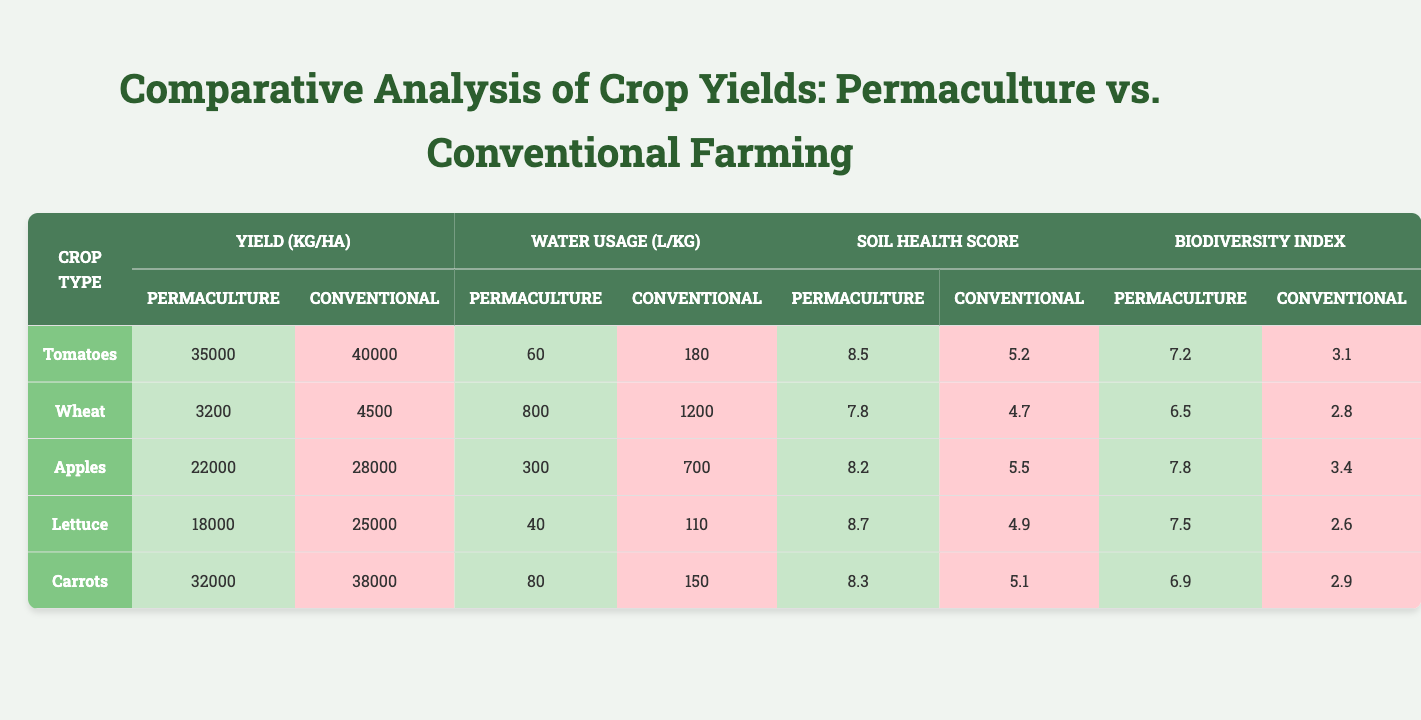What is the yield of tomatoes in the permaculture system? According to the table, the yield of tomatoes grown in the permaculture system is listed as 35,000 kg/ha.
Answer: 35,000 kg/ha What is the water usage for conventional lettuce farming? The table shows that the water usage for conventional lettuce farming is 110 L/kg.
Answer: 110 L/kg Which crop has the highest soil health score in the permaculture system? By comparing the soil health scores in the permaculture section of the table, we see that lettuce has the highest score of 8.7.
Answer: Lettuce How much more yield do conventional tomatoes produce compared to permaculture tomatoes? The yield for conventional tomatoes is 40,000 kg/ha and for permaculture tomatoes, it is 35,000 kg/ha. The difference is 40,000 - 35,000 = 5,000 kg/ha.
Answer: 5,000 kg/ha What is the average biodiversity index for the crops in the permaculture system? The biodiversity indices for permaculture crops are 7.2 (tomatoes), 6.5 (wheat), 7.8 (apples), 7.5 (lettuce), and 6.9 (carrots). To find the average, sum these values: 7.2 + 6.5 + 7.8 + 7.5 + 6.9 = 36.9. Then divide by 5, giving 36.9 / 5 = 7.38.
Answer: 7.38 Is it true that conventional wheat has a higher biodiversity index than conventional apples? The table indicates that the biodiversity index for conventional wheat is 2.8 and for conventional apples, it is 3.4. Since 2.8 is not greater than 3.4, the statement is false.
Answer: False Which farming system uses less water for carrots, permaculture or conventional? The table lists water usage for permaculture carrots as 80 L/kg, while conventional carrots use 150 L/kg. Since 80 is less than 150, permaculture uses less water.
Answer: Permaculture What is the total water usage for tomatoes and carrots in the permaculture system? From the table, the water usage for permaculture tomatoes is 60 L/kg and for carrots is 80 L/kg. Summing these gives 60 + 80 = 140 L/kg.
Answer: 140 L/kg Which crop shows the most significant difference in yield between permaculture and conventional farming? To find which crop has the most significant difference in yield, we look at the differences: tomatoes (5,000 kg/ha), wheat (1,300 kg/ha), apples (6,000 kg/ha), lettuce (7,000 kg/ha), and carrots (6,000 kg/ha). Lettuce has the highest difference of 7,000 kg/ha.
Answer: Lettuce What is the overall soil health score difference between permaculture and conventional farming for wheat? The soil health score for permaculture wheat is 7.8 and for conventional wheat, it is 4.7. The difference is 7.8 - 4.7 = 3.1.
Answer: 3.1 Does permaculture farming produce a higher yield for apples than conventional farming? Permaculture apples yield 22,000 kg/ha, while conventional apples yield 28,000 kg/ha. Since 22,000 is less than 28,000, permaculture produces a lower yield.
Answer: No 